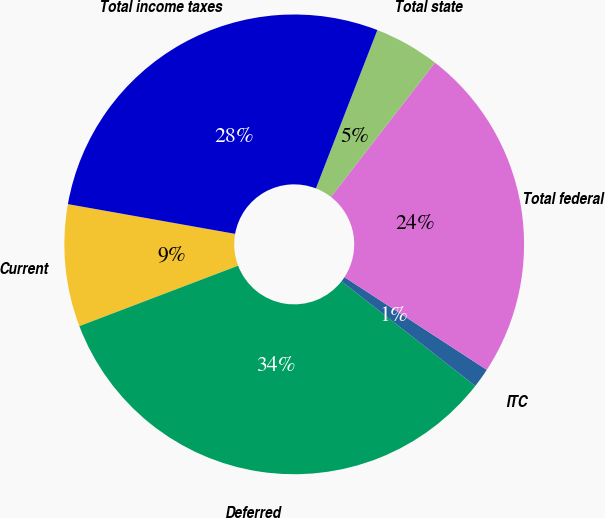<chart> <loc_0><loc_0><loc_500><loc_500><pie_chart><fcel>Current<fcel>Deferred<fcel>ITC<fcel>Total federal<fcel>Total state<fcel>Total income taxes<nl><fcel>8.59%<fcel>33.65%<fcel>1.37%<fcel>23.7%<fcel>4.6%<fcel>28.09%<nl></chart> 